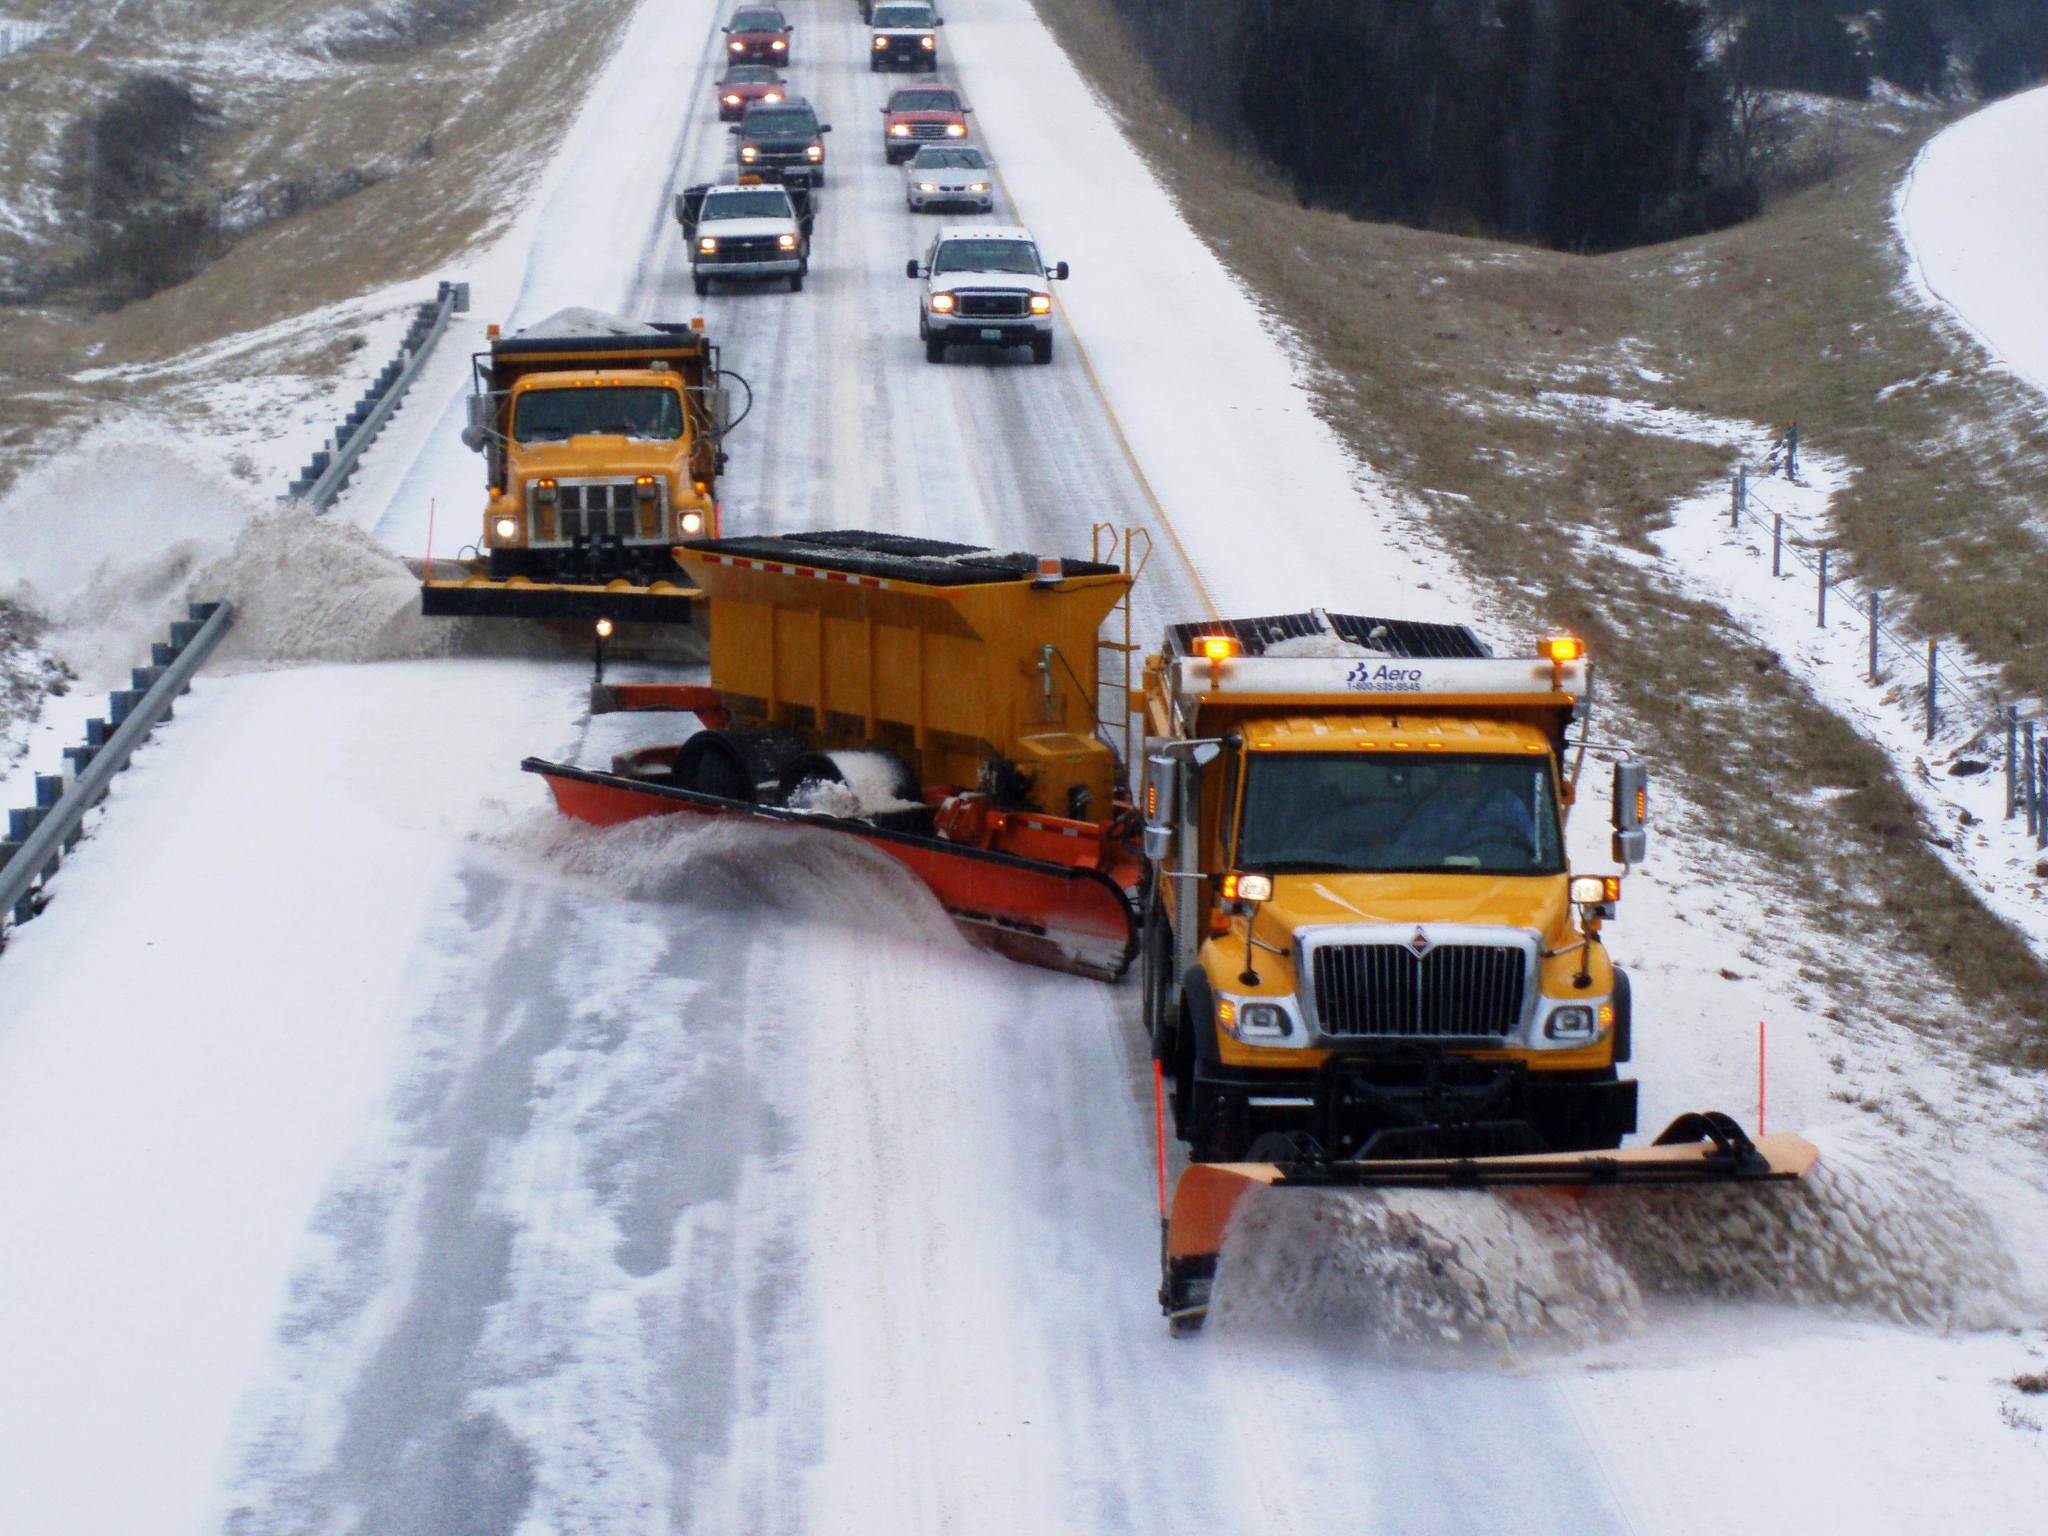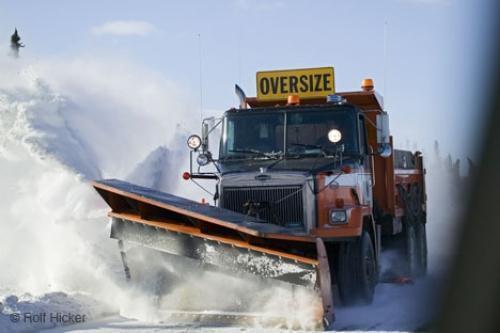The first image is the image on the left, the second image is the image on the right. For the images shown, is this caption "The vehicle in the right image is driving in front of a house" true? Answer yes or no. No. The first image is the image on the left, the second image is the image on the right. Given the left and right images, does the statement "The left and right image contains the same total of white and yellow snow plows." hold true? Answer yes or no. No. 